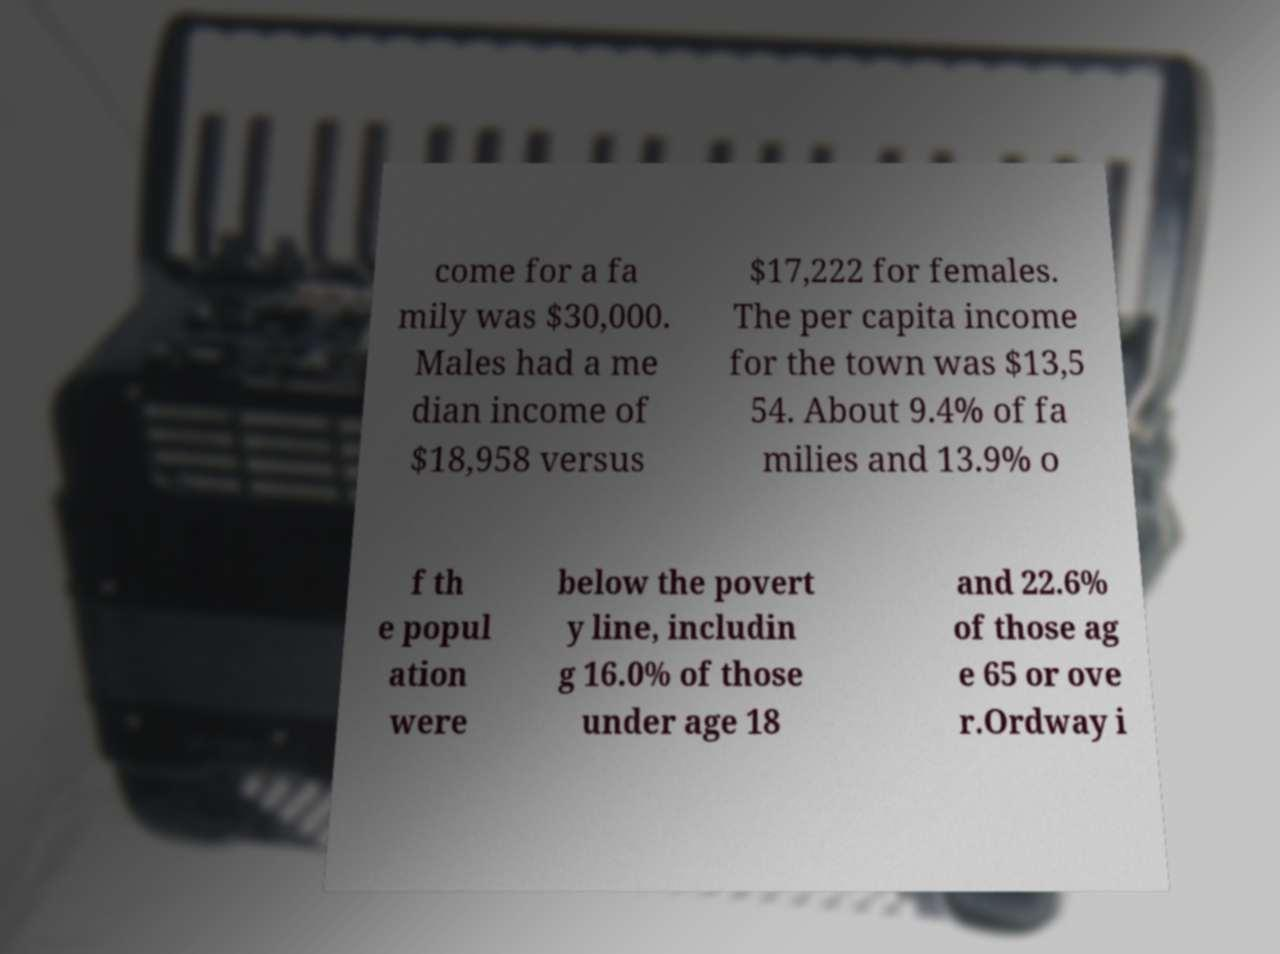Can you read and provide the text displayed in the image?This photo seems to have some interesting text. Can you extract and type it out for me? come for a fa mily was $30,000. Males had a me dian income of $18,958 versus $17,222 for females. The per capita income for the town was $13,5 54. About 9.4% of fa milies and 13.9% o f th e popul ation were below the povert y line, includin g 16.0% of those under age 18 and 22.6% of those ag e 65 or ove r.Ordway i 